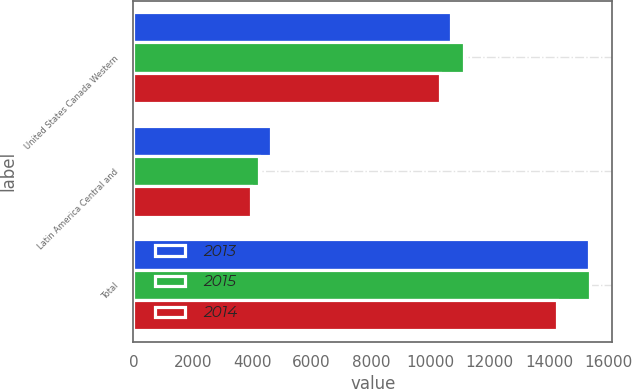<chart> <loc_0><loc_0><loc_500><loc_500><stacked_bar_chart><ecel><fcel>United States Canada Western<fcel>Latin America Central and<fcel>Total<nl><fcel>2013<fcel>10708<fcel>4622<fcel>15330<nl><fcel>2015<fcel>11139<fcel>4221<fcel>15360<nl><fcel>2014<fcel>10311<fcel>3954<fcel>14265<nl></chart> 